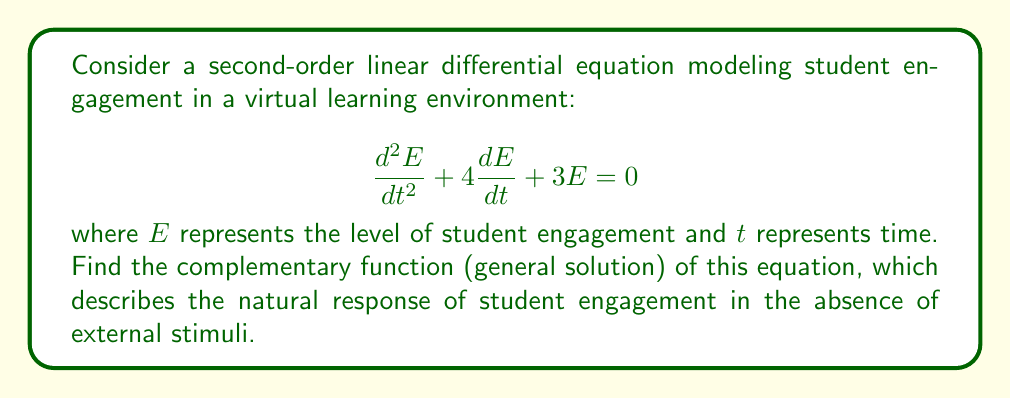Give your solution to this math problem. To find the complementary function, we need to solve the homogeneous equation:

1) First, we assume a solution of the form $E = e^{rt}$, where $r$ is a constant.

2) Substituting this into the original equation:

   $$r^2e^{rt} + 4re^{rt} + 3e^{rt} = 0$$

3) Factoring out $e^{rt}$:

   $$e^{rt}(r^2 + 4r + 3) = 0$$

4) Since $e^{rt} \neq 0$ for any real $t$, we solve the characteristic equation:

   $$r^2 + 4r + 3 = 0$$

5) This is a quadratic equation. We can solve it using the quadratic formula:

   $$r = \frac{-b \pm \sqrt{b^2 - 4ac}}{2a}$$

   where $a=1$, $b=4$, and $c=3$

6) Substituting these values:

   $$r = \frac{-4 \pm \sqrt{16 - 12}}{2} = \frac{-4 \pm \sqrt{4}}{2} = \frac{-4 \pm 2}{2}$$

7) This gives us two roots:

   $$r_1 = \frac{-4 + 2}{2} = -1$$
   $$r_2 = \frac{-4 - 2}{2} = -3$$

8) The general solution (complementary function) is a linear combination of $e^{r_1t}$ and $e^{r_2t}$:

   $$E(t) = c_1e^{-t} + c_2e^{-3t}$$

   where $c_1$ and $c_2$ are arbitrary constants.

This solution represents the natural decay of student engagement over time in a virtual learning environment, with two different rates of decay.
Answer: $$E(t) = c_1e^{-t} + c_2e^{-3t}$$ 